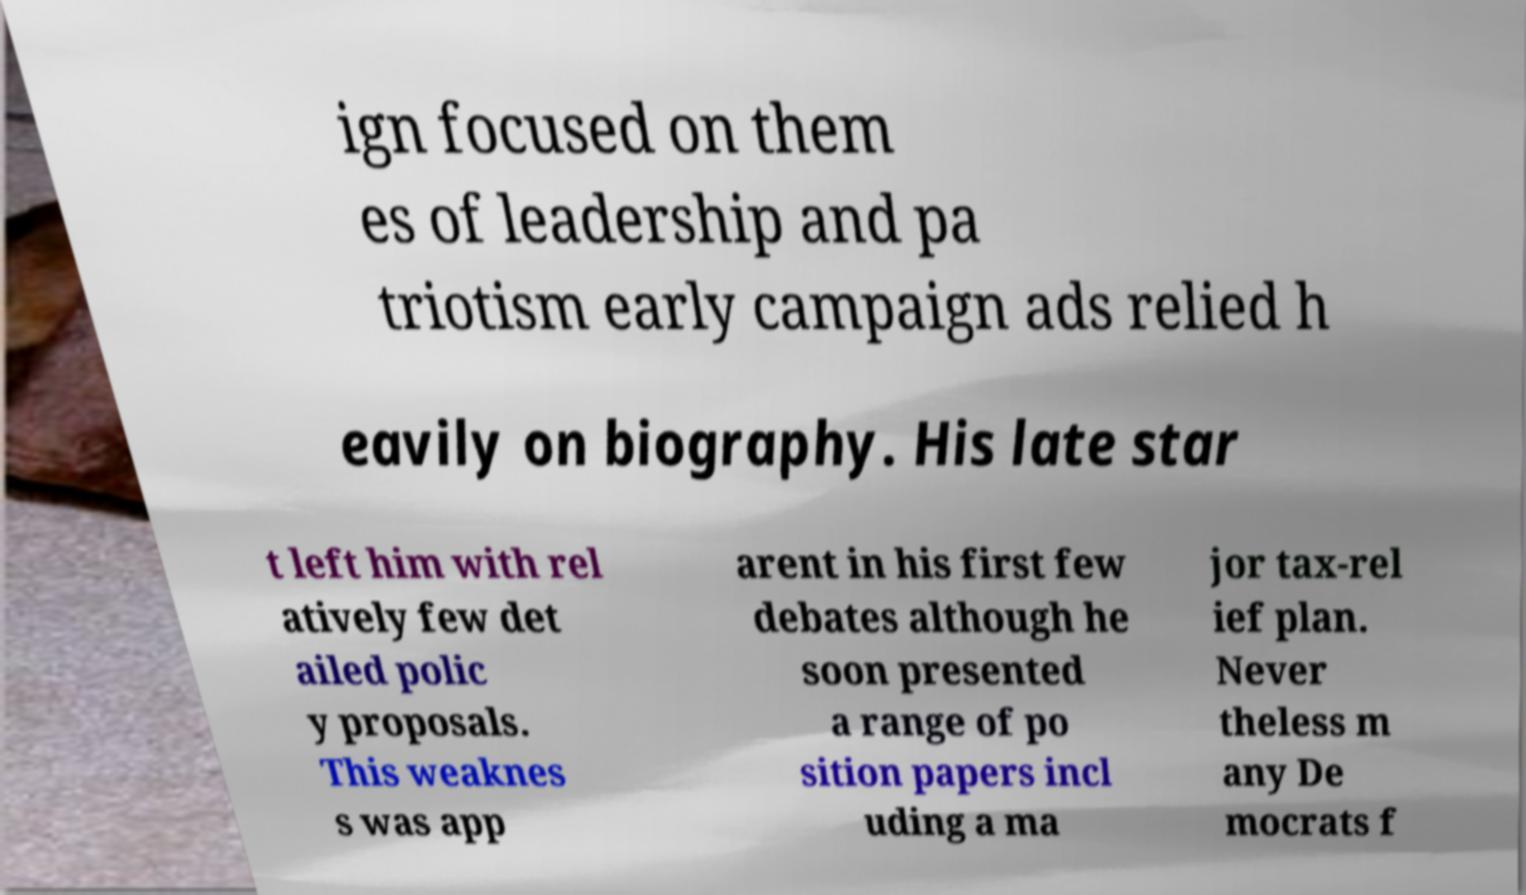Please read and relay the text visible in this image. What does it say? ign focused on them es of leadership and pa triotism early campaign ads relied h eavily on biography. His late star t left him with rel atively few det ailed polic y proposals. This weaknes s was app arent in his first few debates although he soon presented a range of po sition papers incl uding a ma jor tax-rel ief plan. Never theless m any De mocrats f 